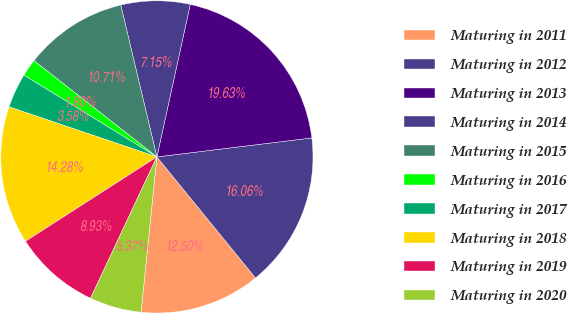<chart> <loc_0><loc_0><loc_500><loc_500><pie_chart><fcel>Maturing in 2011<fcel>Maturing in 2012<fcel>Maturing in 2013<fcel>Maturing in 2014<fcel>Maturing in 2015<fcel>Maturing in 2016<fcel>Maturing in 2017<fcel>Maturing in 2018<fcel>Maturing in 2019<fcel>Maturing in 2020<nl><fcel>12.5%<fcel>16.06%<fcel>19.63%<fcel>7.15%<fcel>10.71%<fcel>1.8%<fcel>3.58%<fcel>14.28%<fcel>8.93%<fcel>5.37%<nl></chart> 